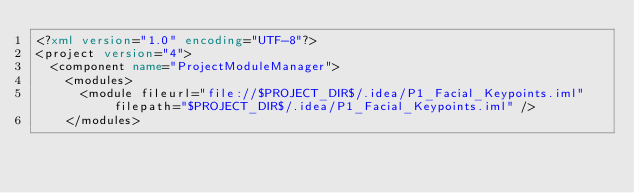Convert code to text. <code><loc_0><loc_0><loc_500><loc_500><_XML_><?xml version="1.0" encoding="UTF-8"?>
<project version="4">
  <component name="ProjectModuleManager">
    <modules>
      <module fileurl="file://$PROJECT_DIR$/.idea/P1_Facial_Keypoints.iml" filepath="$PROJECT_DIR$/.idea/P1_Facial_Keypoints.iml" />
    </modules></code> 